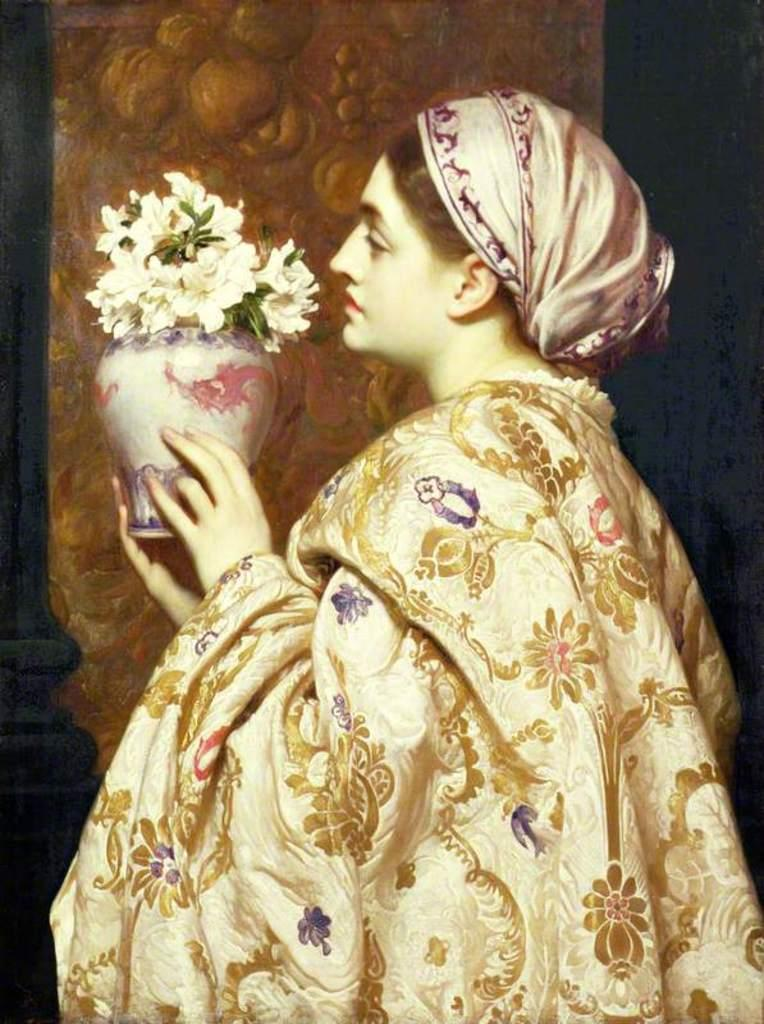What is the main subject of the image? The main subject of the image is a sculpture of a woman. What is the woman holding in her hand? The woman is holding a flower vase in her hand. What type of gate is visible in the image? There is no gate present in the image; it features a sculpture of a woman holding a flower vase. What is the woman's role in the image, and is she a slave? The image does not depict the woman as a slave, nor does it provide any information about her role. The image only shows a sculpture of a woman holding a flower vase. 